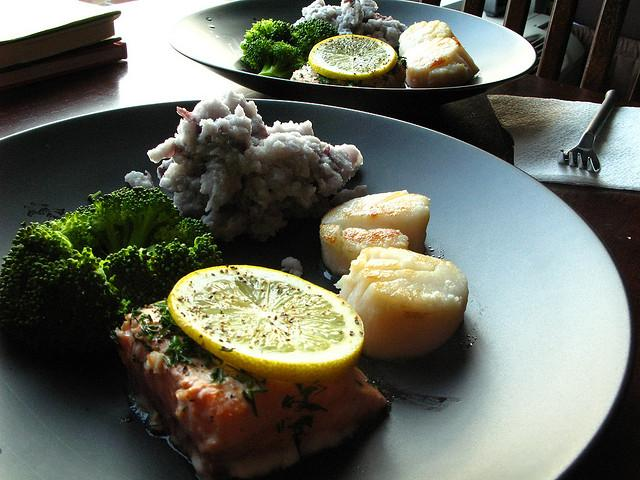Which food here is highest in vitamin B-12? Please explain your reasoning. salmon. Fish is high in vitamin b 12. 